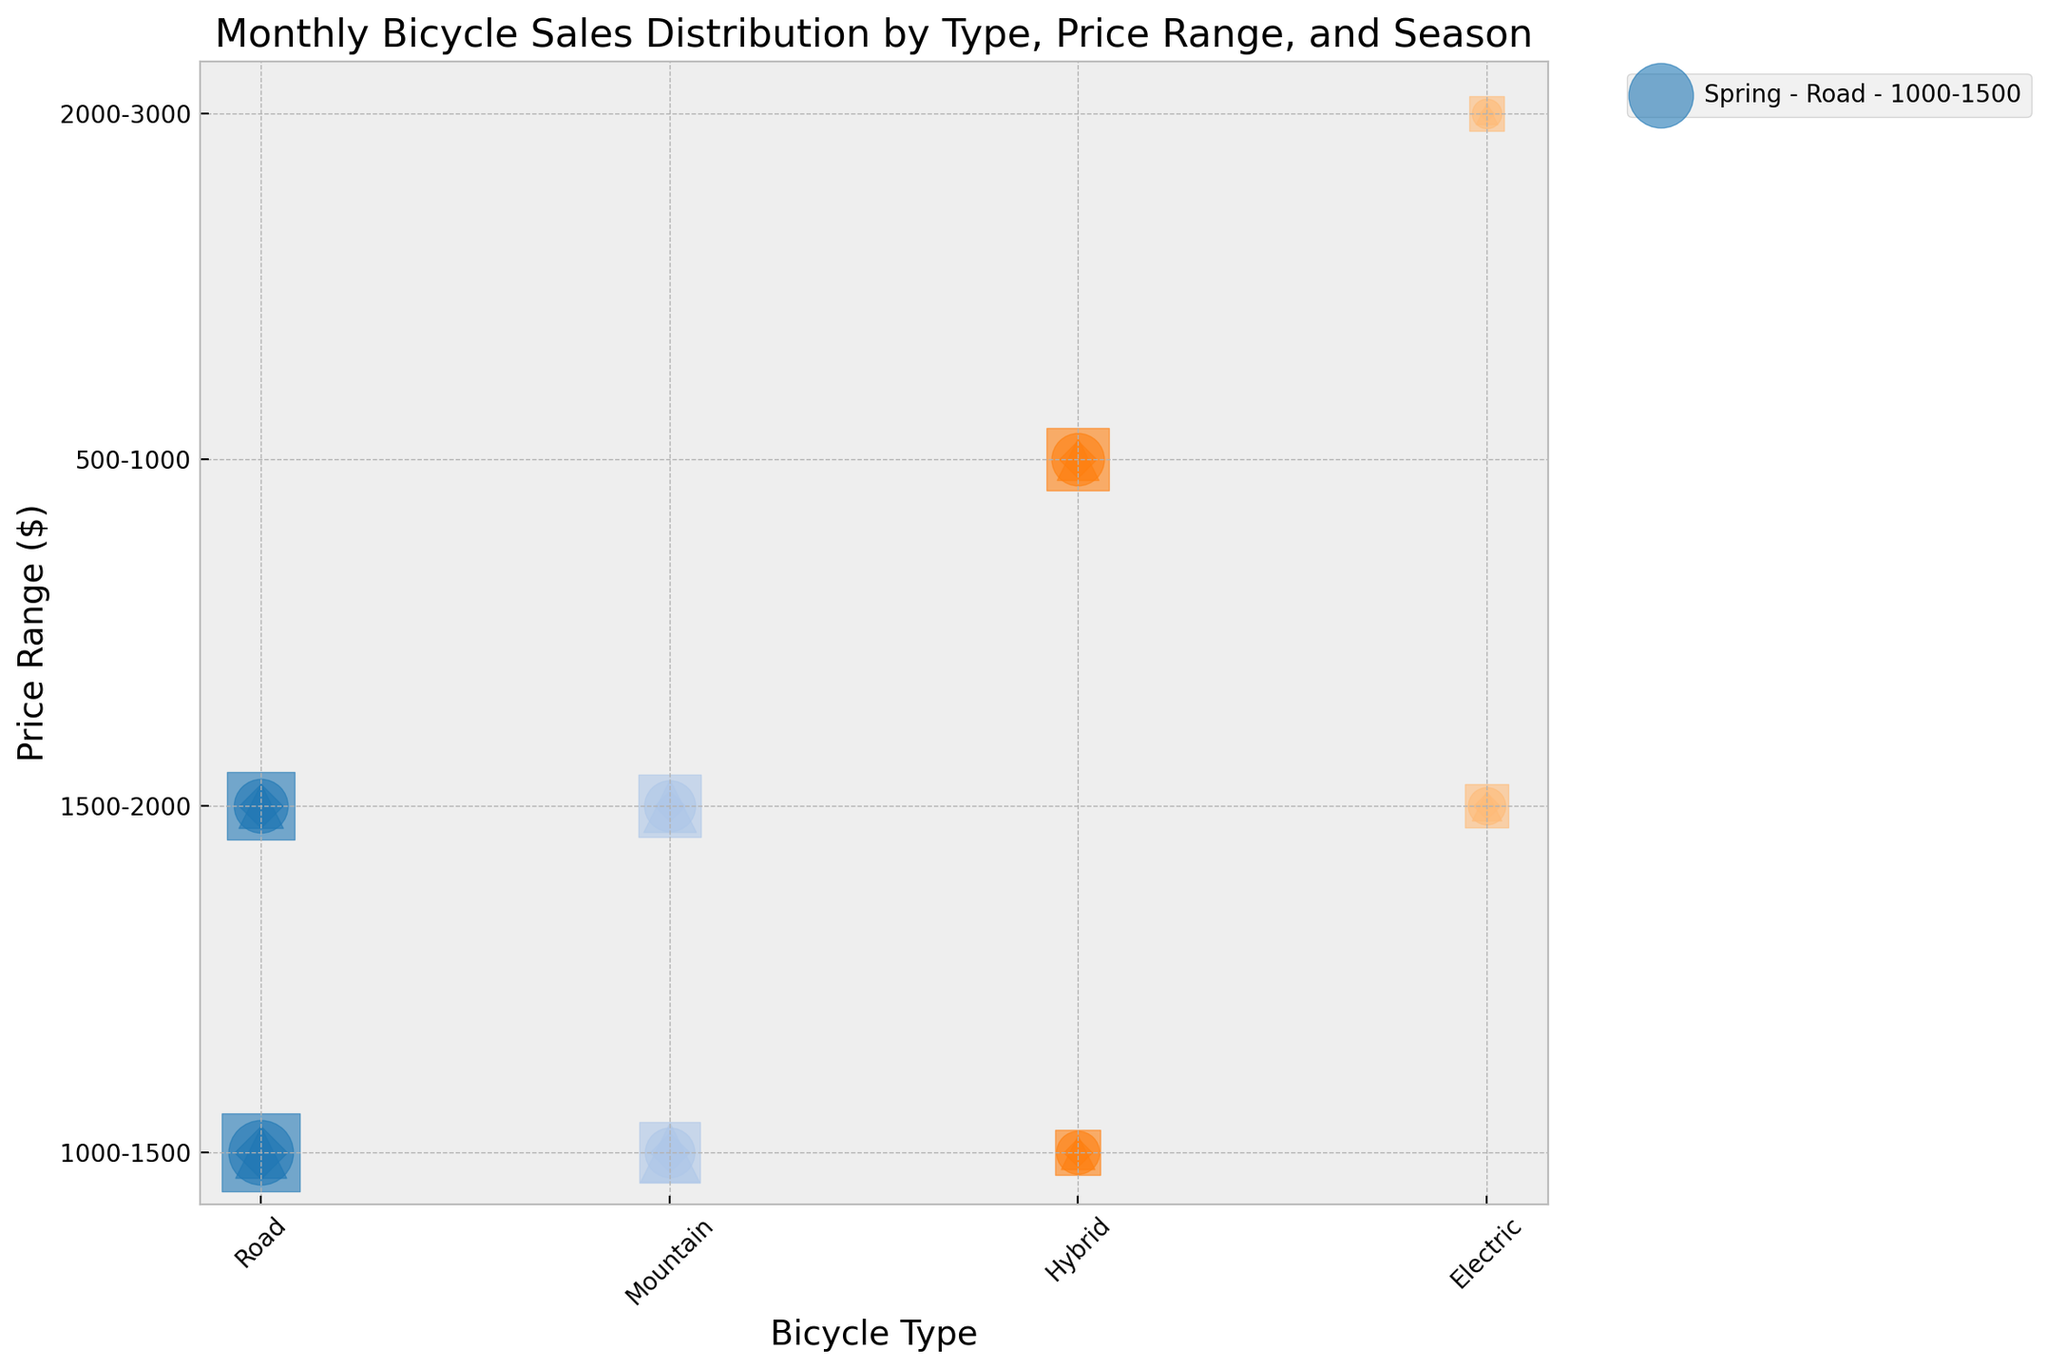Which type of bike has the highest summer sales in the 1000-1500 price range? We need to look at the bubbles for each type of bike in the 1000-1500 price range marked with the summer season marker. The Road bike has the highest sales.
Answer: Road Which season has the highest total sales for Mountain bikes in the 1500-2000 price range? We total the sales for Mountain bikes in each season within the 1500-2000 price range and compare them. Spring (90) + Summer (110) + Autumn (95) + Winter (40), the maximum is in Summer.
Answer: Summer What's the difference in sales between Electric bikes in the 1500-2000 price range and Road bikes in the same range for Spring? From the figure, Electric bikes have 60 sales and Road bikes have 100 sales in Spring within the 1500-2000 price range. The difference is 100 - 60 = 40.
Answer: 40 Which price range shows the highest overall sales for Hybrid bikes in Autumn? We total the sales for each price range of Hybrid bikes in Autumn. 500-1000 range has 75 sales, 1000-1500 range has 65 sales, and 1500-2000 range has no sales recorded. The 500-1000 range has the highest overall sales.
Answer: 500-1000 What is the combined sales of Road bikes for all seasons within the 1500-2000 price range? The combined sales are calculated by summing the sales in each season: Spring (100), Summer (130), Autumn (85), and Winter (55). Adding them gives 100 + 130 + 85 + 55 = 370.
Answer: 370 In Summer, do Mountain bikes in the 1000-1500 price range sell more than Hybrid bikes in the same price range? Comparing the sales for Summer, Mountain bikes have 105 sales while Hybrid bikes have 110 sales. So, Hybrid bikes sell more.
Answer: No Which season features the smallest bubble for Electric bikes in the 2000-3000 price range, and what is the size? We look at the Electric bikes in the 2000-3000 price range across seasons, focusing on the Size attribute for the smallest bubble. Winter has the smallest bubble with a size of 1.
Answer: Winter, 1 How many more sales do Road bikes in the 1000-1500 price range have in Summer compared to Spring? In Summer, Road bikes have 150 sales, and in Spring, they have 120. The difference is 150 - 120 = 30.
Answer: 30 What is the average number of sales for Hybrid bikes in the 1000-1500 price range across all seasons? To find the average, sum the sales from each season and divide by the number of seasons: Spring (80), Summer (85), Autumn (65), and Winter (35). The average is (80 + 85 + 65 + 35)/4 = 66.25.
Answer: 66.25 